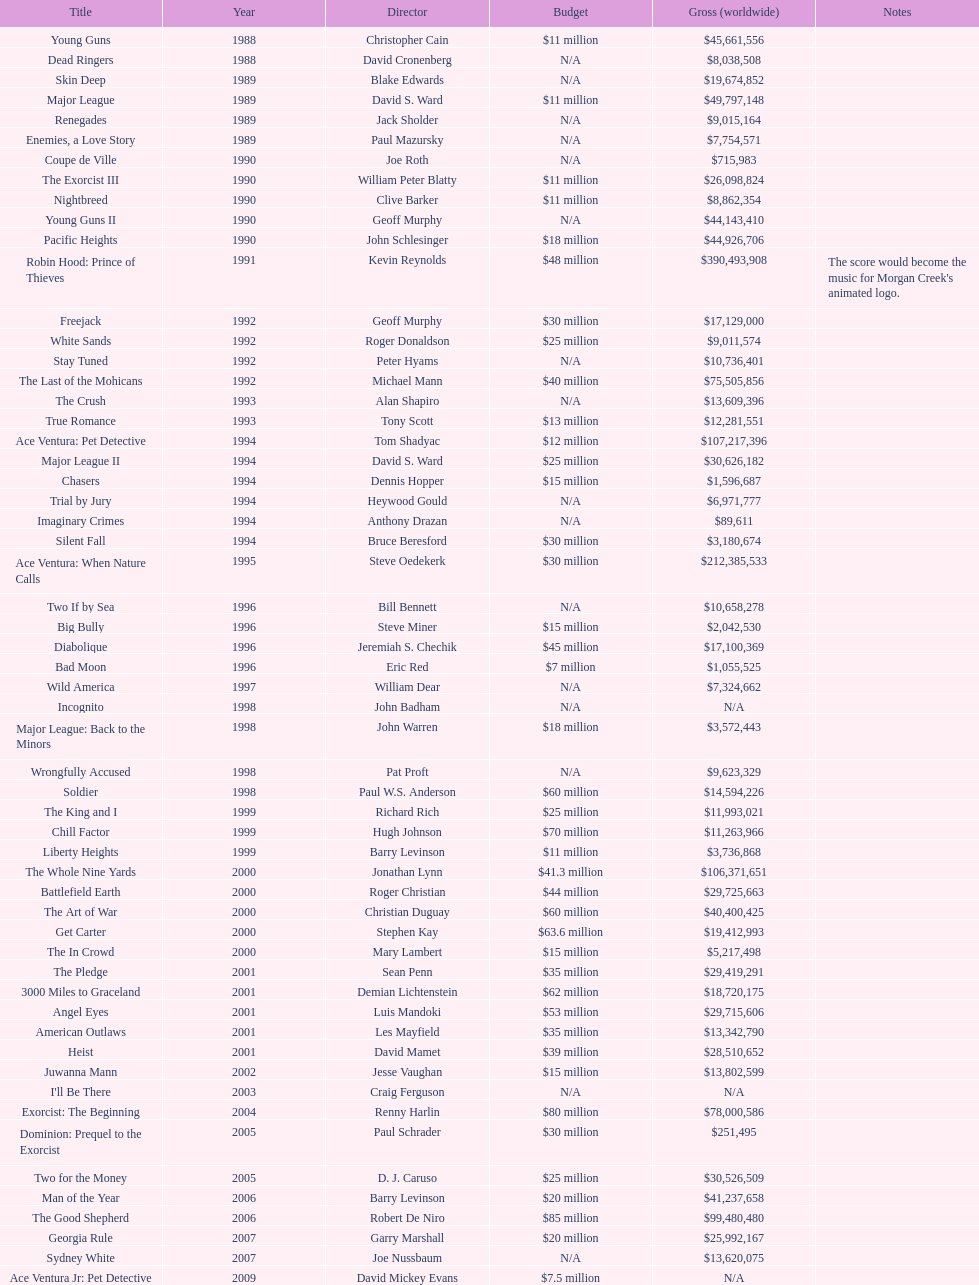Was true romance's box office earnings more or less than that of diabolique? Less. 